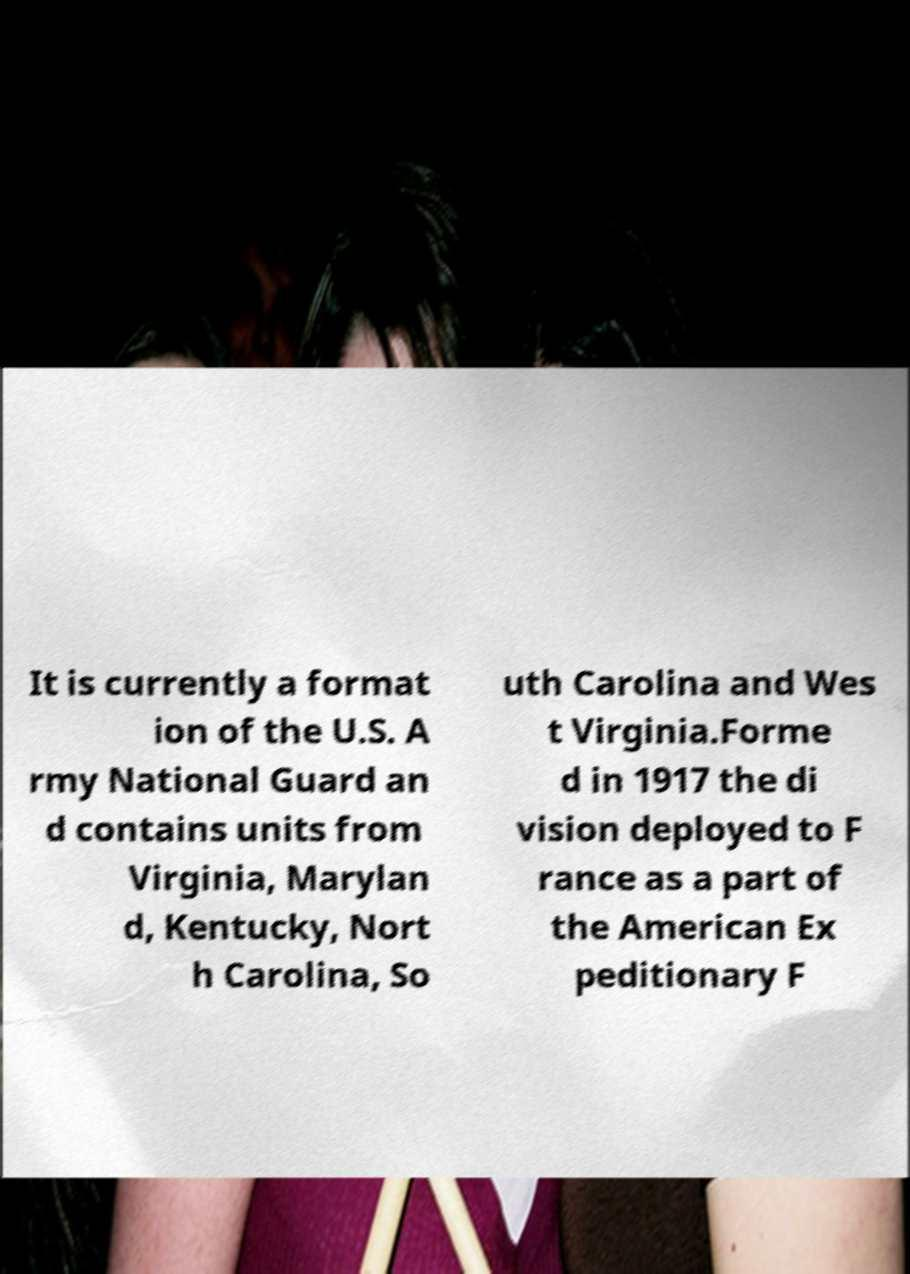Could you assist in decoding the text presented in this image and type it out clearly? It is currently a format ion of the U.S. A rmy National Guard an d contains units from Virginia, Marylan d, Kentucky, Nort h Carolina, So uth Carolina and Wes t Virginia.Forme d in 1917 the di vision deployed to F rance as a part of the American Ex peditionary F 